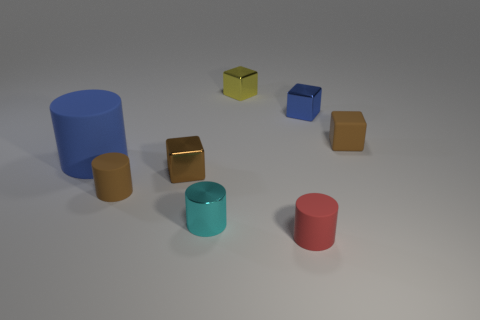Subtract all brown blocks. How many were subtracted if there are1brown blocks left? 1 Subtract all green blocks. Subtract all gray cylinders. How many blocks are left? 4 Add 2 brown metallic things. How many objects exist? 10 Subtract all brown cylinders. Subtract all tiny yellow objects. How many objects are left? 6 Add 4 big rubber things. How many big rubber things are left? 5 Add 2 brown rubber cylinders. How many brown rubber cylinders exist? 3 Subtract 0 yellow balls. How many objects are left? 8 